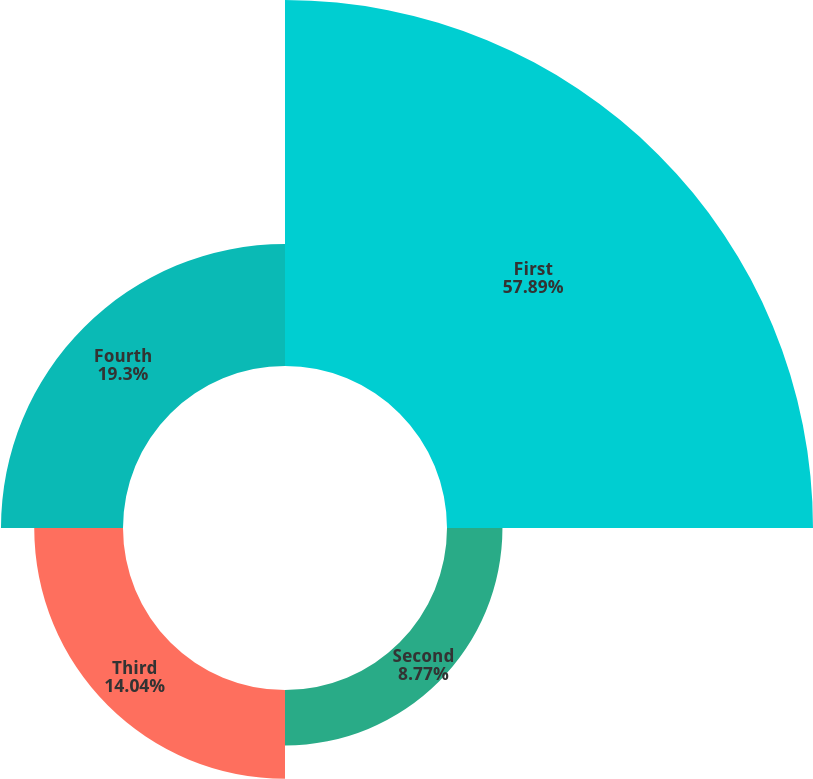Convert chart to OTSL. <chart><loc_0><loc_0><loc_500><loc_500><pie_chart><fcel>First<fcel>Second<fcel>Third<fcel>Fourth<nl><fcel>57.89%<fcel>8.77%<fcel>14.04%<fcel>19.3%<nl></chart> 